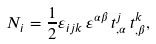Convert formula to latex. <formula><loc_0><loc_0><loc_500><loc_500>N _ { i } = \frac { 1 } { 2 } \varepsilon _ { i j k } \, \varepsilon ^ { \alpha \beta } \, t ^ { j } _ { , \alpha } \, t ^ { k } _ { , \beta } ,</formula> 